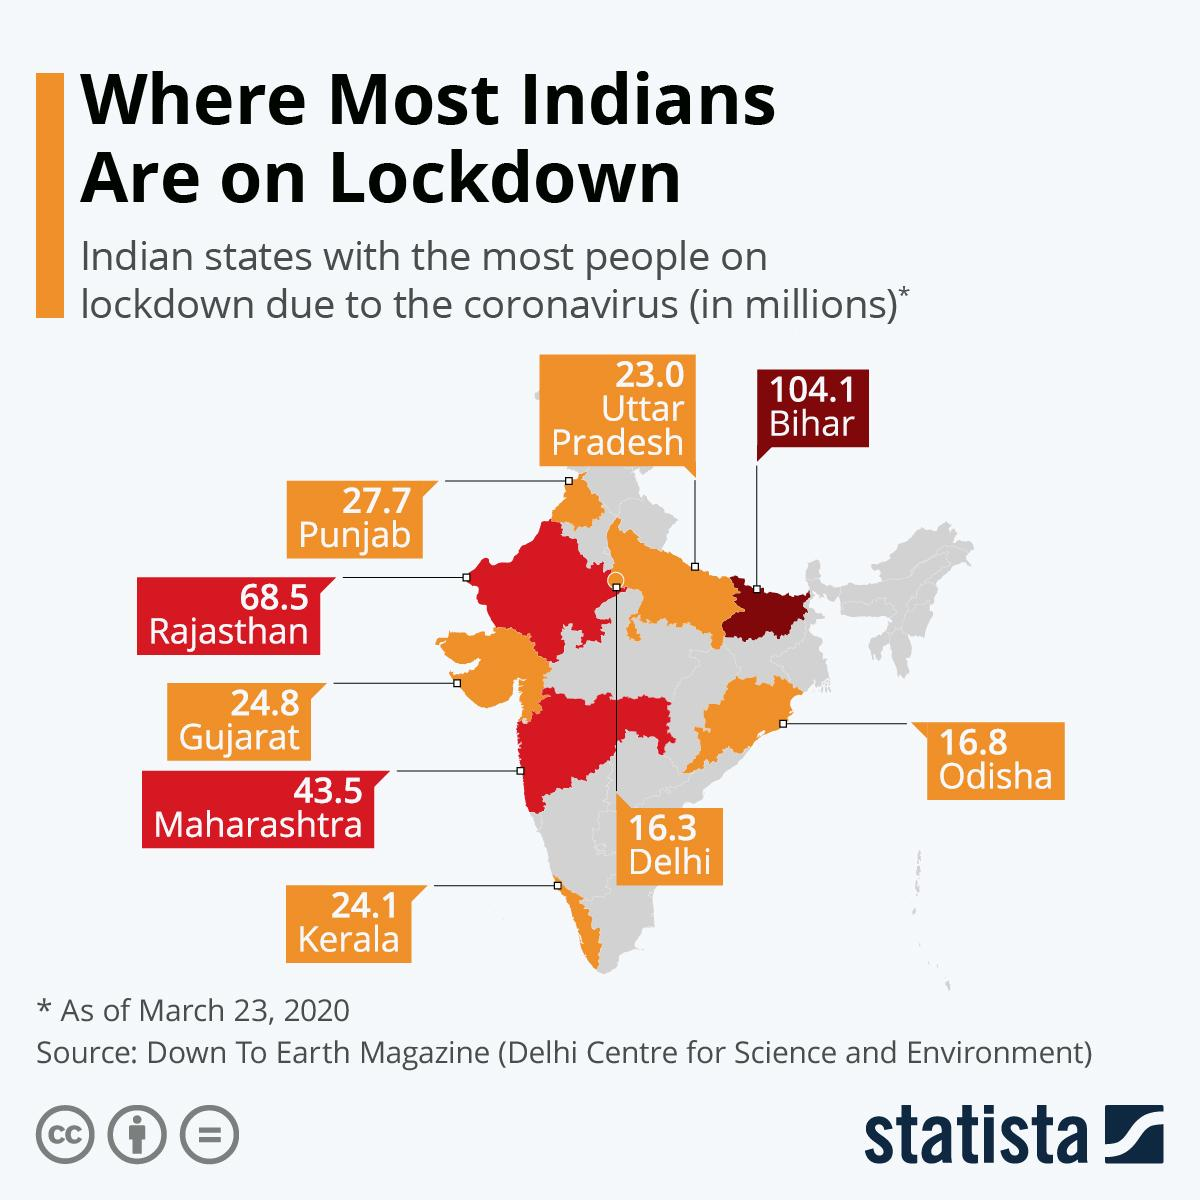Identify some key points in this picture. During the lockdown, the states of Maharashtra, Rajasthan, and Bihar had a population of more than 50 million people. 